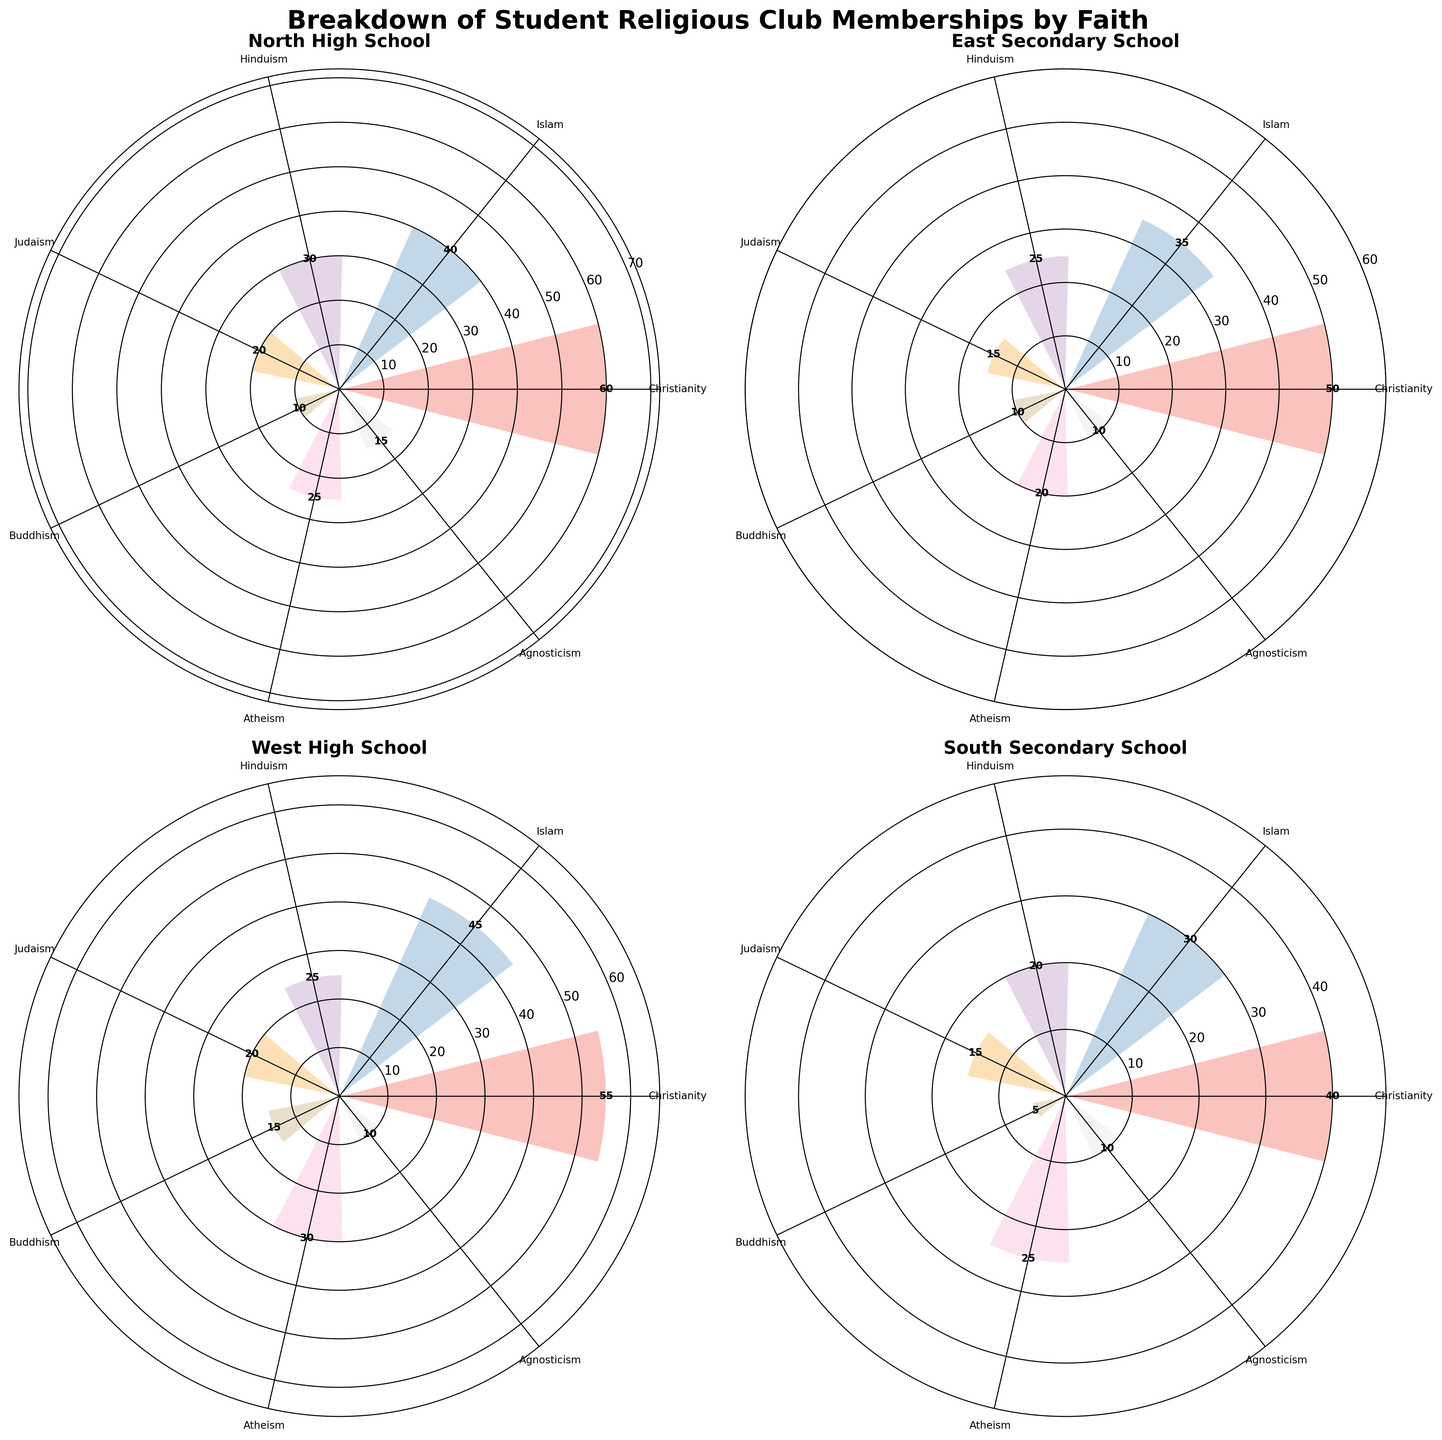what is the title of the figure? The title is typically found at the top of a chart or figure and represents the main topic or theme of the visuals.
Answer: Breakdown of Student Religious Club Memberships by Faith which religion has the most students at North High School? Look at the segment with the largest radius in the North High School subplot to identify the religion with the most students.
Answer: Christianity how many students are members of the Buddhist club at East Secondary School? Find the label for Buddhism in the East Secondary School subplot and read the corresponding value.
Answer: 10 which school has the least number of Agnosticism club members? Identify the values for Agnosticism in each subplot and find the smallest one.
Answer: East Secondary School, West High School, and South Secondary School compare the number of Islamic club members between North High School and South Secondary School. Look at the labels for Islam in both subplots, compare the two values directly.
Answer: North High School has 40, South Secondary School has 30 what is the total number of students in the Christian club across all schools? Add the number of Christian club members from each subplot: 60 + 50 + 55 + 40 = 205
Answer: 205 which school has the highest diversity in religious club memberships? Analyze the range and distribution across the different religions for each school. The subplot with the most even distribution among clubs suggests highest diversity.
Answer: South Secondary School how many more atheists are there in West High School compared to East Secondary School? Find the values for Atheism in both subplots and subtract the smaller from the larger: 30 - 20 = 10
Answer: 10 which school has the largest range in the number of students across different religions? Calculate the difference between the highest and lowest number of students for each subplot and find the largest one.
Answer: North High School (60 - 10 = 50) is there a school where two religions have an equal number of students? Examine the values for each religion in all subplots and see if any two religions have the same number of students.
Answer: None 